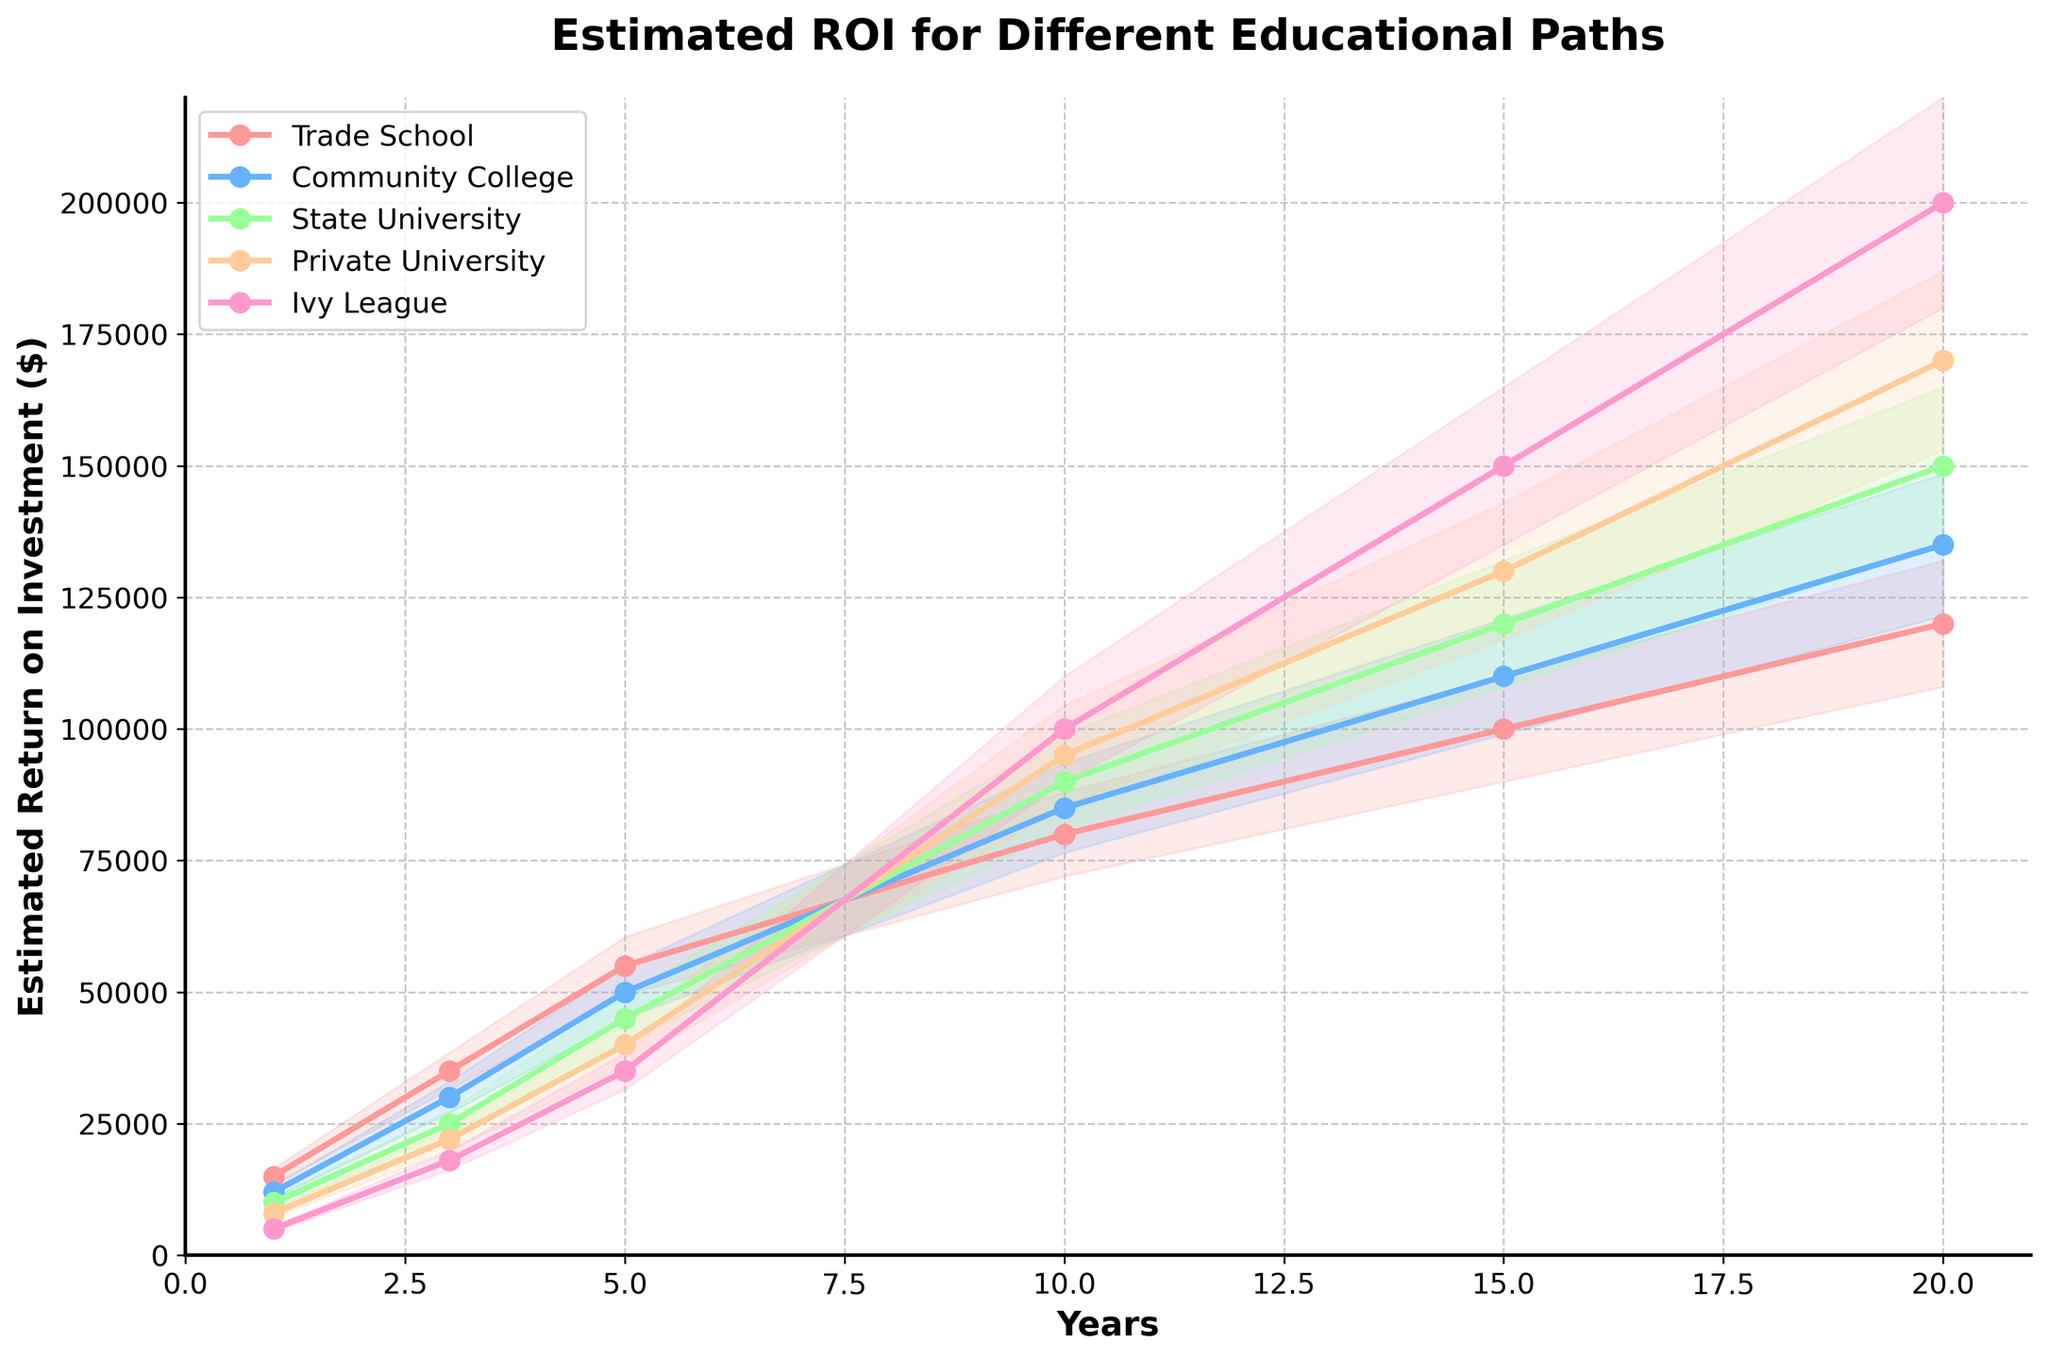What is the title of the figure? The title of the figure is written at the top and states the main topic of the chart.
Answer: Estimated ROI for Different Educational Paths What are the educational paths compared in the figure? The legend on the chart lists the educational paths being compared.
Answer: Trade School, Community College, State University, Private University, Ivy League After 20 years, which educational path has the highest estimated return on investment? The chart shows that the Ivy League path has the highest estimated return on investment at the 20-year mark.
Answer: Ivy League What is the estimated return on investment for Trade School after 5 years? According to the Trade School line on the chart, the estimated return on investment after 5 years is $55,000.
Answer: $55,000 Which educational path shows a higher estimated return on investment at 10 years, Private University or State University? By comparing the lines for Private University and State University at the 10-year mark, it shows that Private University has a higher return on investment.
Answer: Private University How much is the difference in estimated return on investment between Trade School and Ivy League after 15 years? The Trade School return is $100,000 and the Ivy League return is $150,000 at 15 years; the difference is $150,000 - $100,000 = $50,000.
Answer: $50,000 What does the shaded area around each line represent? The shaded area around each line represents the range of potential variations in the estimated return on investment, indicating uncertainty.
Answer: Potential variations/uncertainty Which educational path shows the most significant absolute increase in estimated return on investment from year 1 to year 20? Calculate the increase for each path from year 1 to year 20: Trade School ($120,000 - $15,000 = $105,000), Community College ($135,000 - $12,000 = $123,000), State University ($150,000 - $10,000 = $140,000), Private University ($170,000 - $8,000 = $162,000), Ivy League ($200,000 - $5,000 = $195,000). The Ivy League shows the most significant increase.
Answer: Ivy League Does any educational path have the highest estimated return on investment consistently for all years? By observing the lines, the Ivy League path remains the highest consistently after surpassing other paths by the 10-year mark and continues to grow the fastest.
Answer: Ivy League What is the estimated return on investment for Community College after 10 years? According to the Community College line on the chart, the estimated return on investment after 10 years is $85,000.
Answer: $85,000 